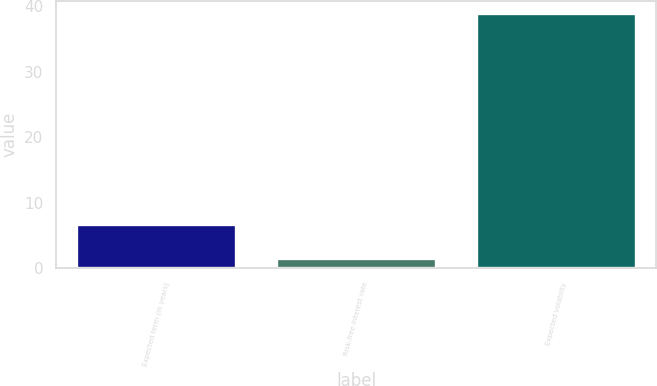<chart> <loc_0><loc_0><loc_500><loc_500><bar_chart><fcel>Expected term (in years)<fcel>Risk-free interest rate<fcel>Expected volatility<nl><fcel>6.7<fcel>1.5<fcel>38.9<nl></chart> 